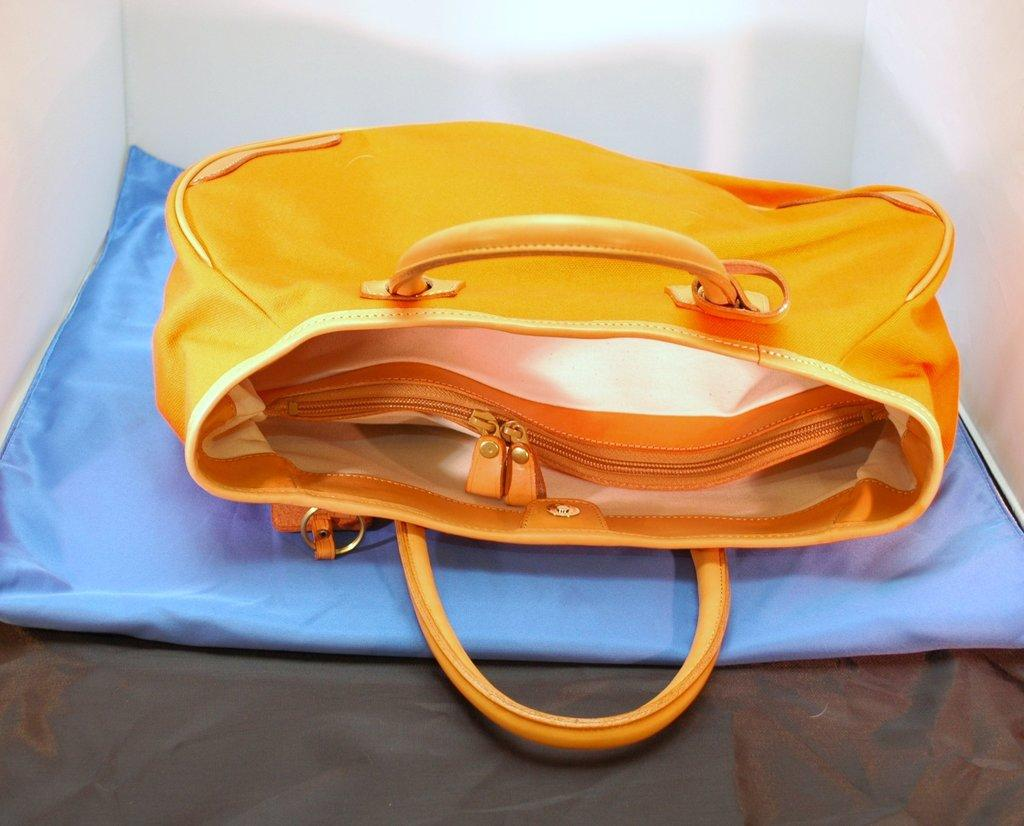What color is the bag in the image? The bag in the image is orange. What feature does the bag have? The bag has zips. What is the bag placed on in the image? The bag is placed on a blue color cloth. What type of trousers can be seen in the image? There are no trousers visible in the image; it only features an orange color bag with zips placed on a blue color cloth. 